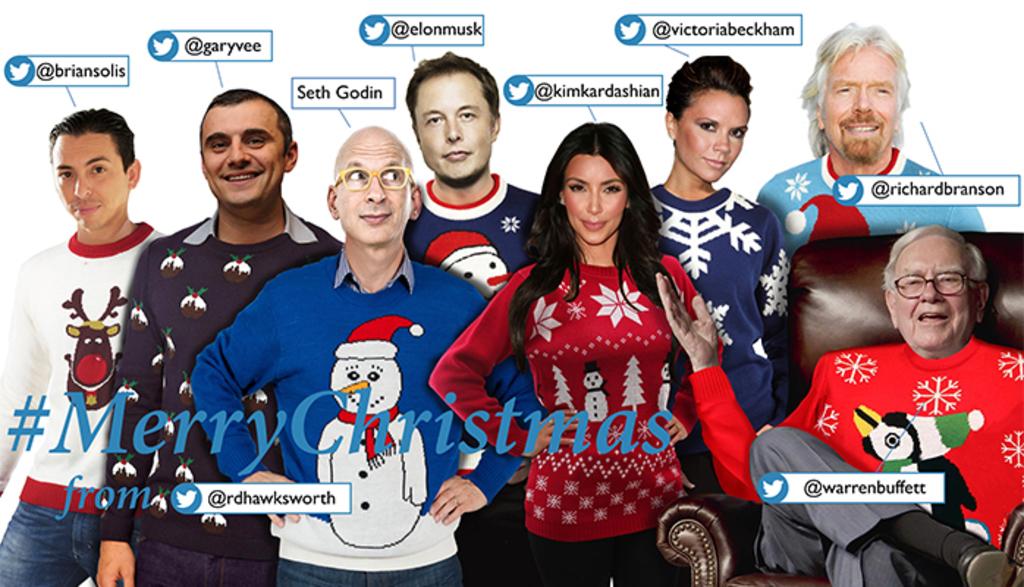What is the twitter handle of the man in the very light blue sweater?
Give a very brief answer. @richardbranson. 